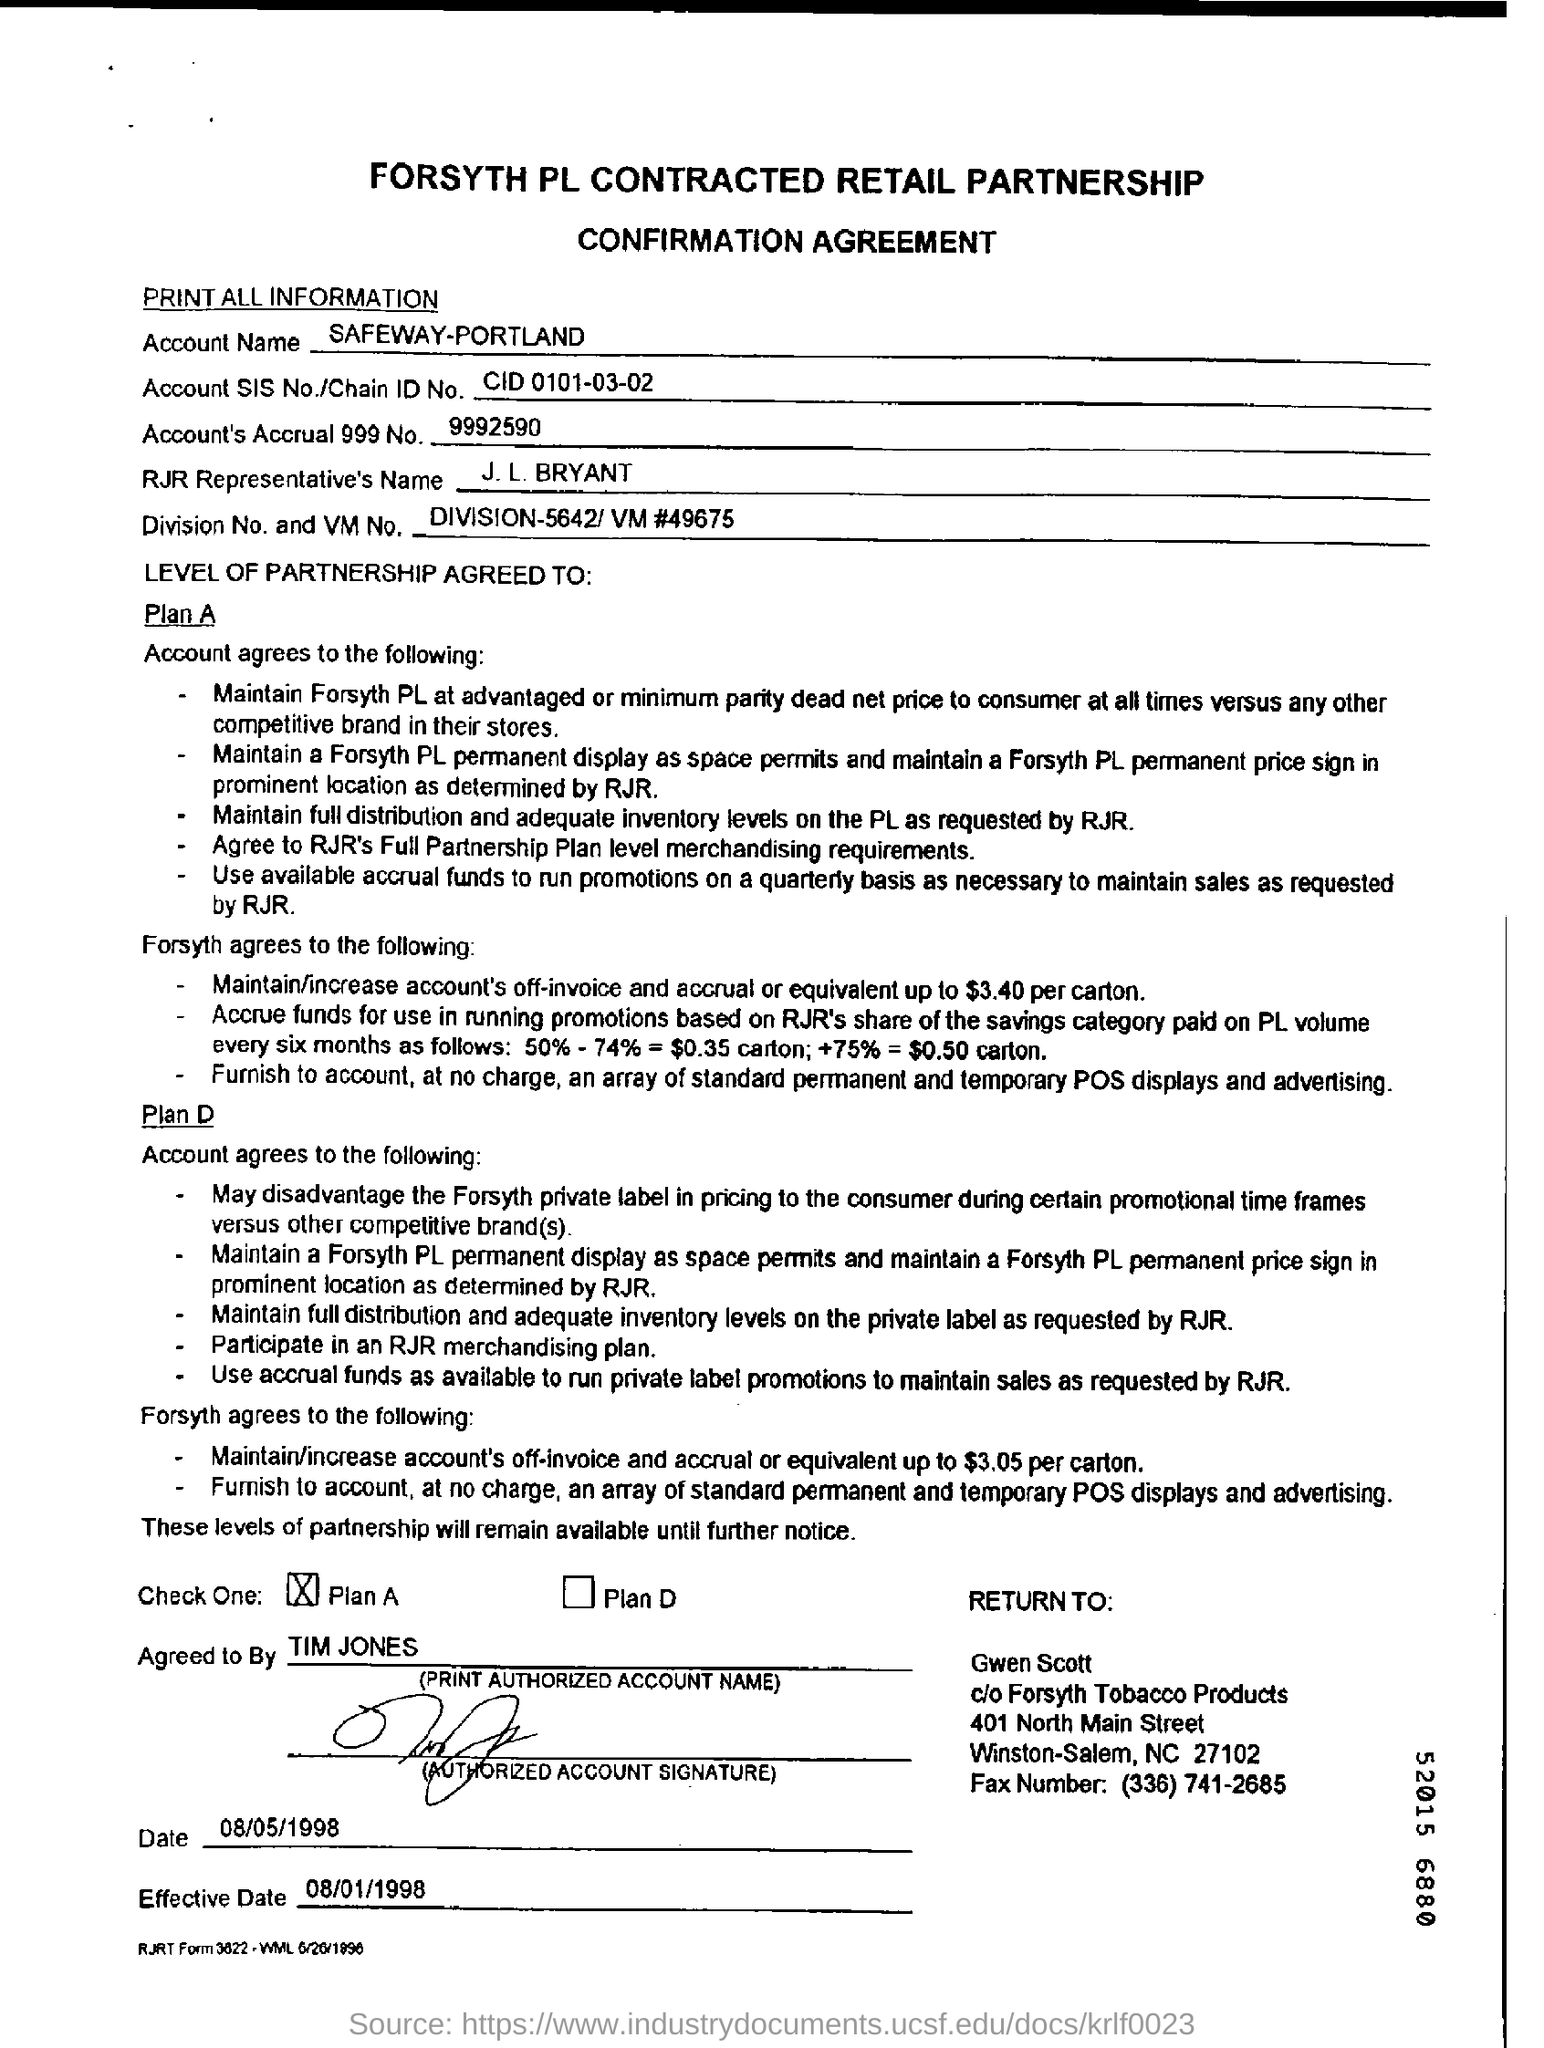Who is the RJR Representative?
Keep it short and to the point. J. L. BRYANT. What is the Effective Date mentioned?
Provide a short and direct response. 08/01/1998. 